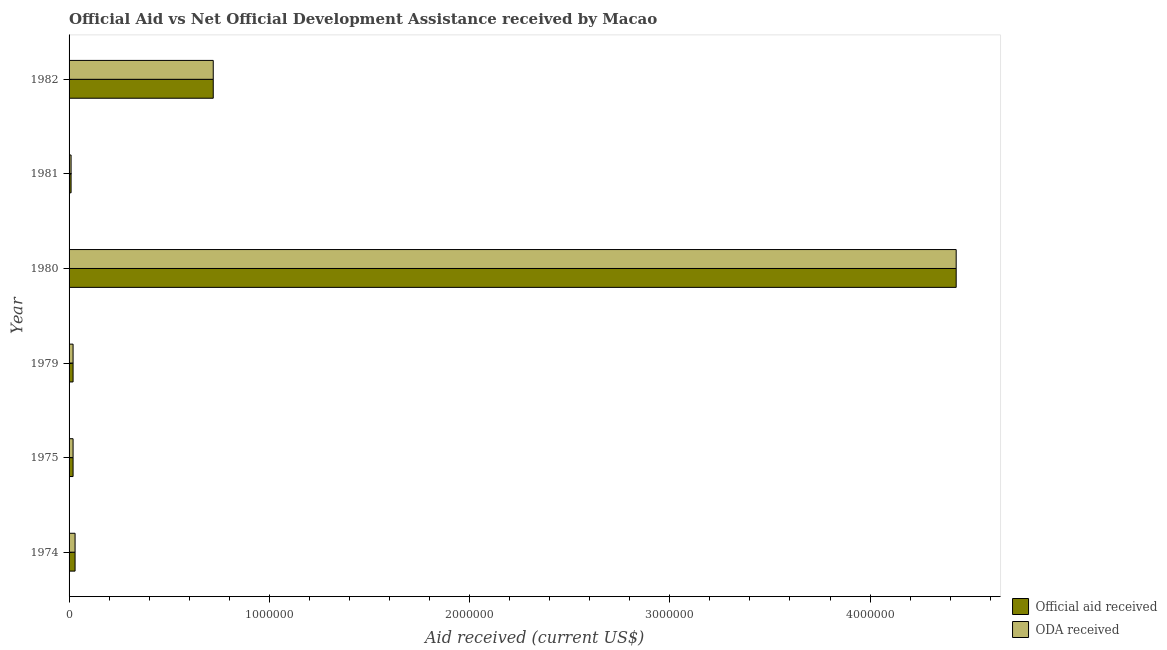How many groups of bars are there?
Give a very brief answer. 6. Are the number of bars per tick equal to the number of legend labels?
Your response must be concise. Yes. Are the number of bars on each tick of the Y-axis equal?
Your answer should be compact. Yes. How many bars are there on the 3rd tick from the top?
Ensure brevity in your answer.  2. How many bars are there on the 1st tick from the bottom?
Provide a succinct answer. 2. In how many cases, is the number of bars for a given year not equal to the number of legend labels?
Make the answer very short. 0. What is the official aid received in 1981?
Make the answer very short. 10000. Across all years, what is the maximum official aid received?
Offer a terse response. 4.43e+06. Across all years, what is the minimum oda received?
Keep it short and to the point. 10000. What is the total oda received in the graph?
Provide a short and direct response. 5.23e+06. What is the difference between the official aid received in 1979 and that in 1980?
Provide a short and direct response. -4.41e+06. What is the difference between the official aid received in 1975 and the oda received in 1980?
Keep it short and to the point. -4.41e+06. What is the average oda received per year?
Ensure brevity in your answer.  8.72e+05. In the year 1980, what is the difference between the official aid received and oda received?
Provide a succinct answer. 0. What is the ratio of the oda received in 1979 to that in 1980?
Offer a terse response. 0.01. What is the difference between the highest and the second highest official aid received?
Offer a terse response. 3.71e+06. What is the difference between the highest and the lowest oda received?
Offer a terse response. 4.42e+06. What does the 1st bar from the top in 1975 represents?
Your response must be concise. ODA received. What does the 1st bar from the bottom in 1982 represents?
Your answer should be compact. Official aid received. How many years are there in the graph?
Keep it short and to the point. 6. Does the graph contain grids?
Keep it short and to the point. No. Where does the legend appear in the graph?
Offer a terse response. Bottom right. How many legend labels are there?
Keep it short and to the point. 2. What is the title of the graph?
Make the answer very short. Official Aid vs Net Official Development Assistance received by Macao . What is the label or title of the X-axis?
Your response must be concise. Aid received (current US$). What is the Aid received (current US$) of ODA received in 1974?
Your answer should be very brief. 3.00e+04. What is the Aid received (current US$) in ODA received in 1975?
Make the answer very short. 2.00e+04. What is the Aid received (current US$) in Official aid received in 1979?
Provide a short and direct response. 2.00e+04. What is the Aid received (current US$) of ODA received in 1979?
Offer a terse response. 2.00e+04. What is the Aid received (current US$) in Official aid received in 1980?
Provide a succinct answer. 4.43e+06. What is the Aid received (current US$) of ODA received in 1980?
Provide a short and direct response. 4.43e+06. What is the Aid received (current US$) in Official aid received in 1982?
Offer a terse response. 7.20e+05. What is the Aid received (current US$) of ODA received in 1982?
Offer a very short reply. 7.20e+05. Across all years, what is the maximum Aid received (current US$) of Official aid received?
Your response must be concise. 4.43e+06. Across all years, what is the maximum Aid received (current US$) in ODA received?
Offer a very short reply. 4.43e+06. Across all years, what is the minimum Aid received (current US$) in ODA received?
Keep it short and to the point. 10000. What is the total Aid received (current US$) of Official aid received in the graph?
Ensure brevity in your answer.  5.23e+06. What is the total Aid received (current US$) in ODA received in the graph?
Provide a short and direct response. 5.23e+06. What is the difference between the Aid received (current US$) in Official aid received in 1974 and that in 1975?
Offer a very short reply. 10000. What is the difference between the Aid received (current US$) in ODA received in 1974 and that in 1975?
Provide a short and direct response. 10000. What is the difference between the Aid received (current US$) in ODA received in 1974 and that in 1979?
Offer a very short reply. 10000. What is the difference between the Aid received (current US$) in Official aid received in 1974 and that in 1980?
Ensure brevity in your answer.  -4.40e+06. What is the difference between the Aid received (current US$) of ODA received in 1974 and that in 1980?
Offer a terse response. -4.40e+06. What is the difference between the Aid received (current US$) in Official aid received in 1974 and that in 1981?
Your answer should be very brief. 2.00e+04. What is the difference between the Aid received (current US$) of Official aid received in 1974 and that in 1982?
Your answer should be compact. -6.90e+05. What is the difference between the Aid received (current US$) in ODA received in 1974 and that in 1982?
Offer a terse response. -6.90e+05. What is the difference between the Aid received (current US$) of ODA received in 1975 and that in 1979?
Provide a succinct answer. 0. What is the difference between the Aid received (current US$) in Official aid received in 1975 and that in 1980?
Your answer should be compact. -4.41e+06. What is the difference between the Aid received (current US$) of ODA received in 1975 and that in 1980?
Provide a succinct answer. -4.41e+06. What is the difference between the Aid received (current US$) in ODA received in 1975 and that in 1981?
Provide a short and direct response. 10000. What is the difference between the Aid received (current US$) of Official aid received in 1975 and that in 1982?
Provide a succinct answer. -7.00e+05. What is the difference between the Aid received (current US$) of ODA received in 1975 and that in 1982?
Give a very brief answer. -7.00e+05. What is the difference between the Aid received (current US$) of Official aid received in 1979 and that in 1980?
Offer a terse response. -4.41e+06. What is the difference between the Aid received (current US$) of ODA received in 1979 and that in 1980?
Provide a short and direct response. -4.41e+06. What is the difference between the Aid received (current US$) in Official aid received in 1979 and that in 1981?
Give a very brief answer. 10000. What is the difference between the Aid received (current US$) in Official aid received in 1979 and that in 1982?
Give a very brief answer. -7.00e+05. What is the difference between the Aid received (current US$) in ODA received in 1979 and that in 1982?
Offer a terse response. -7.00e+05. What is the difference between the Aid received (current US$) of Official aid received in 1980 and that in 1981?
Give a very brief answer. 4.42e+06. What is the difference between the Aid received (current US$) in ODA received in 1980 and that in 1981?
Offer a very short reply. 4.42e+06. What is the difference between the Aid received (current US$) of Official aid received in 1980 and that in 1982?
Your answer should be compact. 3.71e+06. What is the difference between the Aid received (current US$) in ODA received in 1980 and that in 1982?
Give a very brief answer. 3.71e+06. What is the difference between the Aid received (current US$) in Official aid received in 1981 and that in 1982?
Your answer should be compact. -7.10e+05. What is the difference between the Aid received (current US$) of ODA received in 1981 and that in 1982?
Offer a very short reply. -7.10e+05. What is the difference between the Aid received (current US$) of Official aid received in 1974 and the Aid received (current US$) of ODA received in 1975?
Your response must be concise. 10000. What is the difference between the Aid received (current US$) of Official aid received in 1974 and the Aid received (current US$) of ODA received in 1980?
Offer a terse response. -4.40e+06. What is the difference between the Aid received (current US$) of Official aid received in 1974 and the Aid received (current US$) of ODA received in 1982?
Keep it short and to the point. -6.90e+05. What is the difference between the Aid received (current US$) of Official aid received in 1975 and the Aid received (current US$) of ODA received in 1979?
Offer a very short reply. 0. What is the difference between the Aid received (current US$) in Official aid received in 1975 and the Aid received (current US$) in ODA received in 1980?
Provide a succinct answer. -4.41e+06. What is the difference between the Aid received (current US$) in Official aid received in 1975 and the Aid received (current US$) in ODA received in 1981?
Give a very brief answer. 10000. What is the difference between the Aid received (current US$) in Official aid received in 1975 and the Aid received (current US$) in ODA received in 1982?
Provide a succinct answer. -7.00e+05. What is the difference between the Aid received (current US$) of Official aid received in 1979 and the Aid received (current US$) of ODA received in 1980?
Your response must be concise. -4.41e+06. What is the difference between the Aid received (current US$) in Official aid received in 1979 and the Aid received (current US$) in ODA received in 1981?
Offer a very short reply. 10000. What is the difference between the Aid received (current US$) of Official aid received in 1979 and the Aid received (current US$) of ODA received in 1982?
Give a very brief answer. -7.00e+05. What is the difference between the Aid received (current US$) in Official aid received in 1980 and the Aid received (current US$) in ODA received in 1981?
Ensure brevity in your answer.  4.42e+06. What is the difference between the Aid received (current US$) of Official aid received in 1980 and the Aid received (current US$) of ODA received in 1982?
Your response must be concise. 3.71e+06. What is the difference between the Aid received (current US$) of Official aid received in 1981 and the Aid received (current US$) of ODA received in 1982?
Your answer should be compact. -7.10e+05. What is the average Aid received (current US$) in Official aid received per year?
Offer a terse response. 8.72e+05. What is the average Aid received (current US$) in ODA received per year?
Keep it short and to the point. 8.72e+05. In the year 1974, what is the difference between the Aid received (current US$) in Official aid received and Aid received (current US$) in ODA received?
Offer a very short reply. 0. In the year 1975, what is the difference between the Aid received (current US$) in Official aid received and Aid received (current US$) in ODA received?
Give a very brief answer. 0. In the year 1979, what is the difference between the Aid received (current US$) of Official aid received and Aid received (current US$) of ODA received?
Keep it short and to the point. 0. In the year 1980, what is the difference between the Aid received (current US$) of Official aid received and Aid received (current US$) of ODA received?
Provide a short and direct response. 0. In the year 1981, what is the difference between the Aid received (current US$) of Official aid received and Aid received (current US$) of ODA received?
Your response must be concise. 0. What is the ratio of the Aid received (current US$) of Official aid received in 1974 to that in 1975?
Your response must be concise. 1.5. What is the ratio of the Aid received (current US$) of ODA received in 1974 to that in 1975?
Keep it short and to the point. 1.5. What is the ratio of the Aid received (current US$) in Official aid received in 1974 to that in 1979?
Your answer should be compact. 1.5. What is the ratio of the Aid received (current US$) in ODA received in 1974 to that in 1979?
Offer a terse response. 1.5. What is the ratio of the Aid received (current US$) in Official aid received in 1974 to that in 1980?
Offer a terse response. 0.01. What is the ratio of the Aid received (current US$) in ODA received in 1974 to that in 1980?
Offer a terse response. 0.01. What is the ratio of the Aid received (current US$) in Official aid received in 1974 to that in 1981?
Provide a succinct answer. 3. What is the ratio of the Aid received (current US$) of Official aid received in 1974 to that in 1982?
Make the answer very short. 0.04. What is the ratio of the Aid received (current US$) in ODA received in 1974 to that in 1982?
Provide a short and direct response. 0.04. What is the ratio of the Aid received (current US$) in Official aid received in 1975 to that in 1979?
Offer a very short reply. 1. What is the ratio of the Aid received (current US$) of ODA received in 1975 to that in 1979?
Keep it short and to the point. 1. What is the ratio of the Aid received (current US$) in Official aid received in 1975 to that in 1980?
Provide a succinct answer. 0. What is the ratio of the Aid received (current US$) in ODA received in 1975 to that in 1980?
Provide a short and direct response. 0. What is the ratio of the Aid received (current US$) of Official aid received in 1975 to that in 1981?
Make the answer very short. 2. What is the ratio of the Aid received (current US$) of ODA received in 1975 to that in 1981?
Keep it short and to the point. 2. What is the ratio of the Aid received (current US$) in Official aid received in 1975 to that in 1982?
Provide a succinct answer. 0.03. What is the ratio of the Aid received (current US$) of ODA received in 1975 to that in 1982?
Your answer should be very brief. 0.03. What is the ratio of the Aid received (current US$) of Official aid received in 1979 to that in 1980?
Offer a terse response. 0. What is the ratio of the Aid received (current US$) of ODA received in 1979 to that in 1980?
Your answer should be very brief. 0. What is the ratio of the Aid received (current US$) of Official aid received in 1979 to that in 1981?
Offer a terse response. 2. What is the ratio of the Aid received (current US$) of Official aid received in 1979 to that in 1982?
Your answer should be very brief. 0.03. What is the ratio of the Aid received (current US$) of ODA received in 1979 to that in 1982?
Offer a very short reply. 0.03. What is the ratio of the Aid received (current US$) in Official aid received in 1980 to that in 1981?
Make the answer very short. 443. What is the ratio of the Aid received (current US$) of ODA received in 1980 to that in 1981?
Give a very brief answer. 443. What is the ratio of the Aid received (current US$) in Official aid received in 1980 to that in 1982?
Give a very brief answer. 6.15. What is the ratio of the Aid received (current US$) of ODA received in 1980 to that in 1982?
Your answer should be compact. 6.15. What is the ratio of the Aid received (current US$) in Official aid received in 1981 to that in 1982?
Give a very brief answer. 0.01. What is the ratio of the Aid received (current US$) of ODA received in 1981 to that in 1982?
Provide a succinct answer. 0.01. What is the difference between the highest and the second highest Aid received (current US$) of Official aid received?
Ensure brevity in your answer.  3.71e+06. What is the difference between the highest and the second highest Aid received (current US$) of ODA received?
Your answer should be very brief. 3.71e+06. What is the difference between the highest and the lowest Aid received (current US$) of Official aid received?
Your response must be concise. 4.42e+06. What is the difference between the highest and the lowest Aid received (current US$) of ODA received?
Provide a succinct answer. 4.42e+06. 